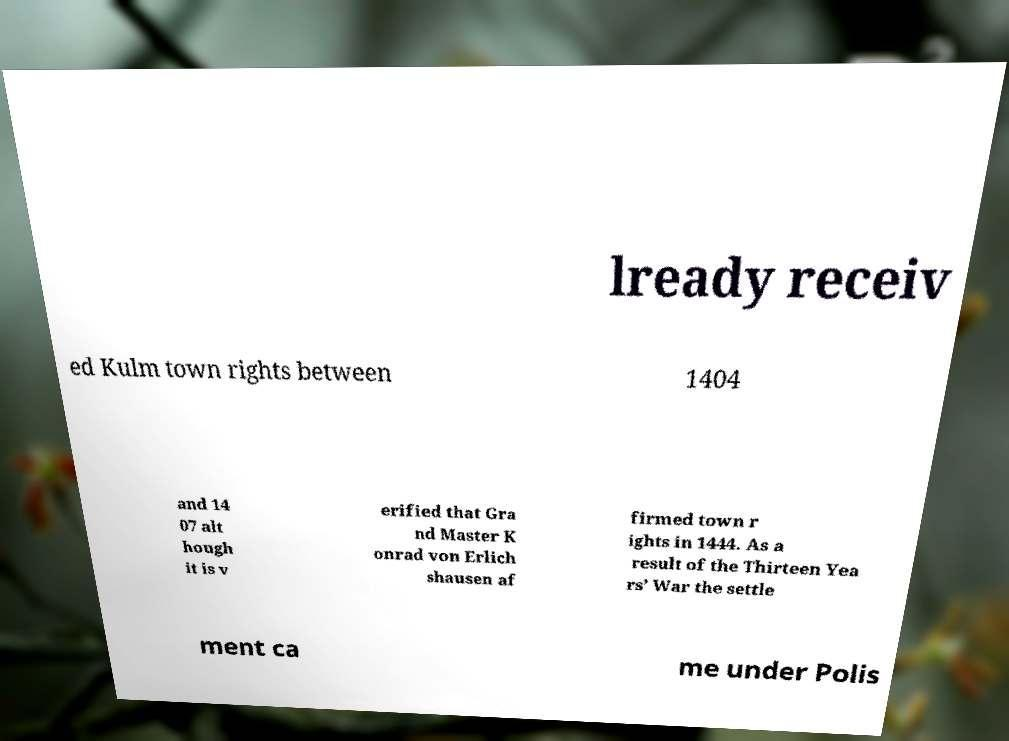There's text embedded in this image that I need extracted. Can you transcribe it verbatim? lready receiv ed Kulm town rights between 1404 and 14 07 alt hough it is v erified that Gra nd Master K onrad von Erlich shausen af firmed town r ights in 1444. As a result of the Thirteen Yea rs’ War the settle ment ca me under Polis 